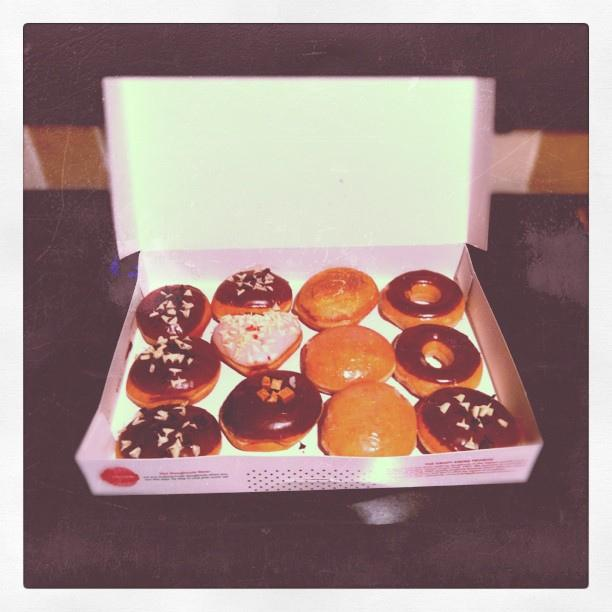What is the box made of? Please explain your reasoning. paper. Many carry out food establishments prefer to use recyclable paper or cardboard containers. paper recycles more easily than most styrofoam. 